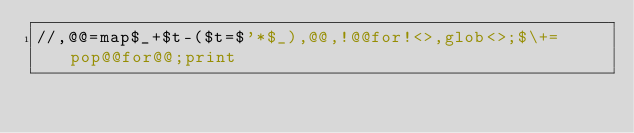Convert code to text. <code><loc_0><loc_0><loc_500><loc_500><_Perl_>//,@@=map$_+$t-($t=$'*$_),@@,!@@for!<>,glob<>;$\+=pop@@for@@;print</code> 